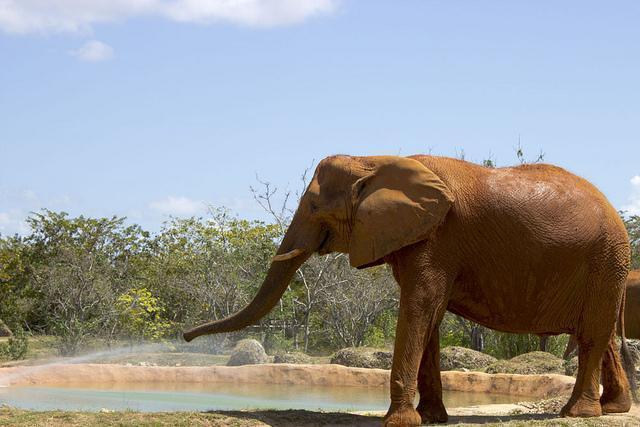How many airplanes are there flying in the photo?
Give a very brief answer. 0. 